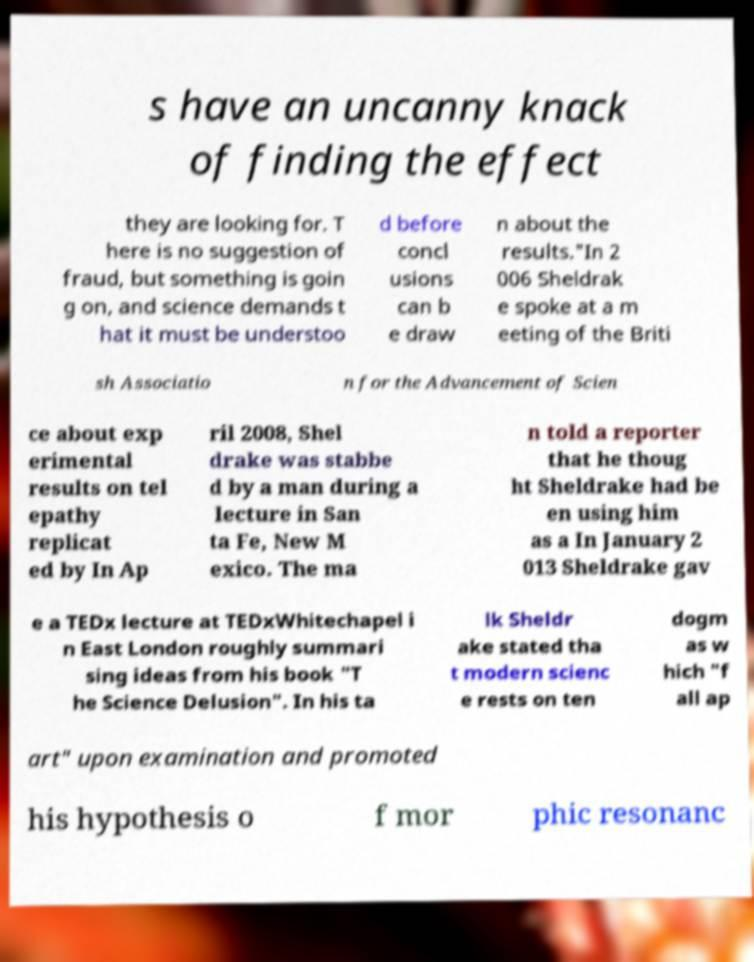For documentation purposes, I need the text within this image transcribed. Could you provide that? s have an uncanny knack of finding the effect they are looking for. T here is no suggestion of fraud, but something is goin g on, and science demands t hat it must be understoo d before concl usions can b e draw n about the results."In 2 006 Sheldrak e spoke at a m eeting of the Briti sh Associatio n for the Advancement of Scien ce about exp erimental results on tel epathy replicat ed by In Ap ril 2008, Shel drake was stabbe d by a man during a lecture in San ta Fe, New M exico. The ma n told a reporter that he thoug ht Sheldrake had be en using him as a In January 2 013 Sheldrake gav e a TEDx lecture at TEDxWhitechapel i n East London roughly summari sing ideas from his book "T he Science Delusion". In his ta lk Sheldr ake stated tha t modern scienc e rests on ten dogm as w hich "f all ap art" upon examination and promoted his hypothesis o f mor phic resonanc 